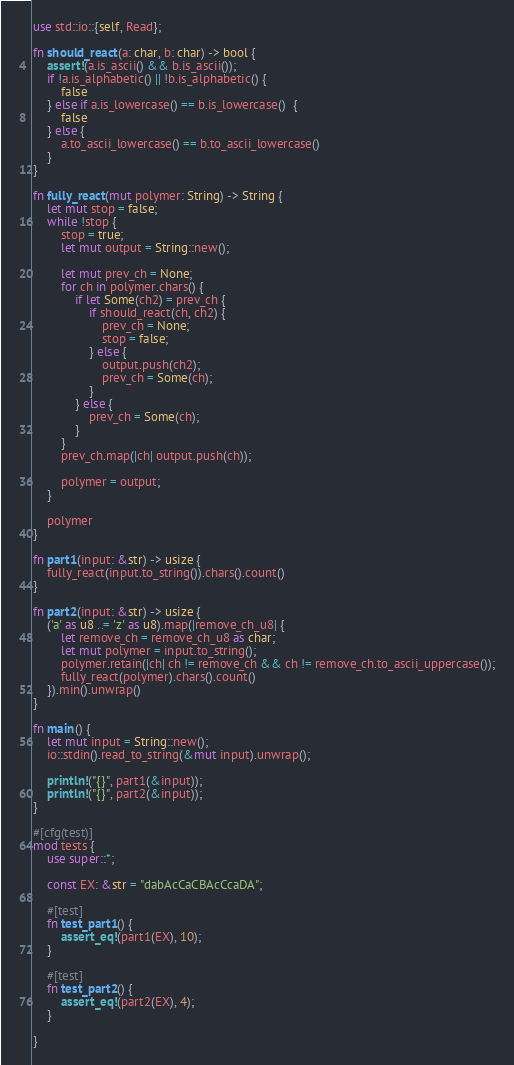Convert code to text. <code><loc_0><loc_0><loc_500><loc_500><_Rust_>use std::io::{self, Read};

fn should_react(a: char, b: char) -> bool {
    assert!(a.is_ascii() && b.is_ascii());
    if !a.is_alphabetic() || !b.is_alphabetic() {
        false
    } else if a.is_lowercase() == b.is_lowercase()  {
        false
    } else {
        a.to_ascii_lowercase() == b.to_ascii_lowercase()
    }
}

fn fully_react(mut polymer: String) -> String {
    let mut stop = false;
    while !stop {
        stop = true;
        let mut output = String::new();

        let mut prev_ch = None;
        for ch in polymer.chars() {
            if let Some(ch2) = prev_ch {
                if should_react(ch, ch2) {
                    prev_ch = None;
                    stop = false;
                } else {
                    output.push(ch2);
                    prev_ch = Some(ch);
                }
            } else {
                prev_ch = Some(ch);
            }
        }
        prev_ch.map(|ch| output.push(ch));

        polymer = output;
    }

    polymer
}

fn part1(input: &str) -> usize {
    fully_react(input.to_string()).chars().count()
}

fn part2(input: &str) -> usize {
    ('a' as u8 ..= 'z' as u8).map(|remove_ch_u8| {
        let remove_ch = remove_ch_u8 as char;
        let mut polymer = input.to_string();
        polymer.retain(|ch| ch != remove_ch && ch != remove_ch.to_ascii_uppercase());
        fully_react(polymer).chars().count()
    }).min().unwrap()
}

fn main() {
    let mut input = String::new();
    io::stdin().read_to_string(&mut input).unwrap();

    println!("{}", part1(&input));
    println!("{}", part2(&input));
}

#[cfg(test)]
mod tests {
    use super::*;

    const EX: &str = "dabAcCaCBAcCcaDA";

    #[test]
    fn test_part1() {
        assert_eq!(part1(EX), 10);
    }

    #[test]
    fn test_part2() {
        assert_eq!(part2(EX), 4);
    }

}
</code> 